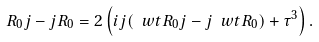Convert formula to latex. <formula><loc_0><loc_0><loc_500><loc_500>R _ { 0 } j - j R _ { 0 } = 2 \left ( i j ( \ w t R _ { 0 } j - j \ w t R _ { 0 } ) + \tau ^ { 3 } \right ) .</formula> 